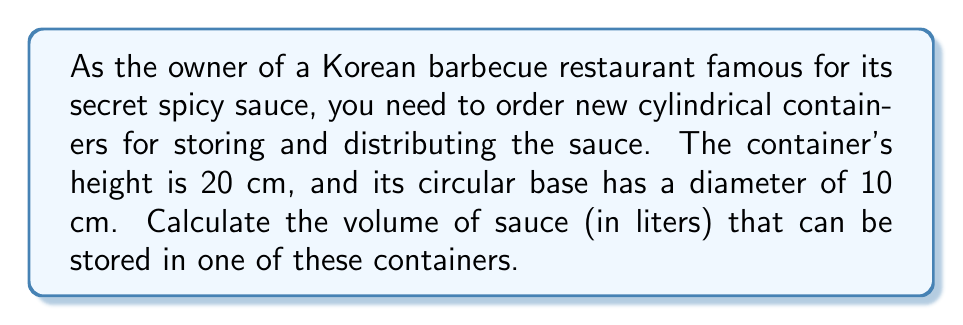Could you help me with this problem? To solve this problem, we need to follow these steps:

1. Identify the formula for the volume of a cylinder:
   $$V = \pi r^2 h$$
   where $V$ is the volume, $r$ is the radius of the base, and $h$ is the height of the cylinder.

2. Determine the radius:
   The diameter is 10 cm, so the radius is half of that:
   $$r = \frac{10 \text{ cm}}{2} = 5 \text{ cm}$$

3. Use the given height:
   $$h = 20 \text{ cm}$$

4. Substitute these values into the formula:
   $$V = \pi (5 \text{ cm})^2 (20 \text{ cm})$$

5. Calculate:
   $$V = \pi (25 \text{ cm}^2) (20 \text{ cm}) = 500\pi \text{ cm}^3$$

6. Evaluate $\pi$ to 2 decimal places:
   $$V \approx 500 \times 3.14 = 1,570 \text{ cm}^3$$

7. Convert cubic centimeters to liters:
   $$1,570 \text{ cm}^3 \times \frac{1 \text{ L}}{1000 \text{ cm}^3} = 1.57 \text{ L}$$

Therefore, the cylindrical container can hold approximately 1.57 liters of the secret spicy sauce.
Answer: 1.57 liters 